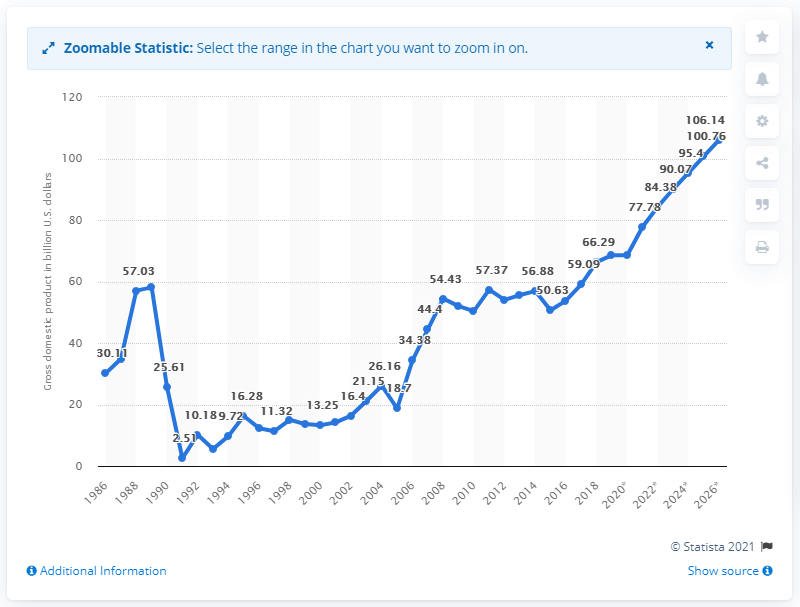Mention a couple of crucial points in this snapshot. In 2019, the gross domestic product of Bulgaria was estimated to be 68.56 billion dollars. 